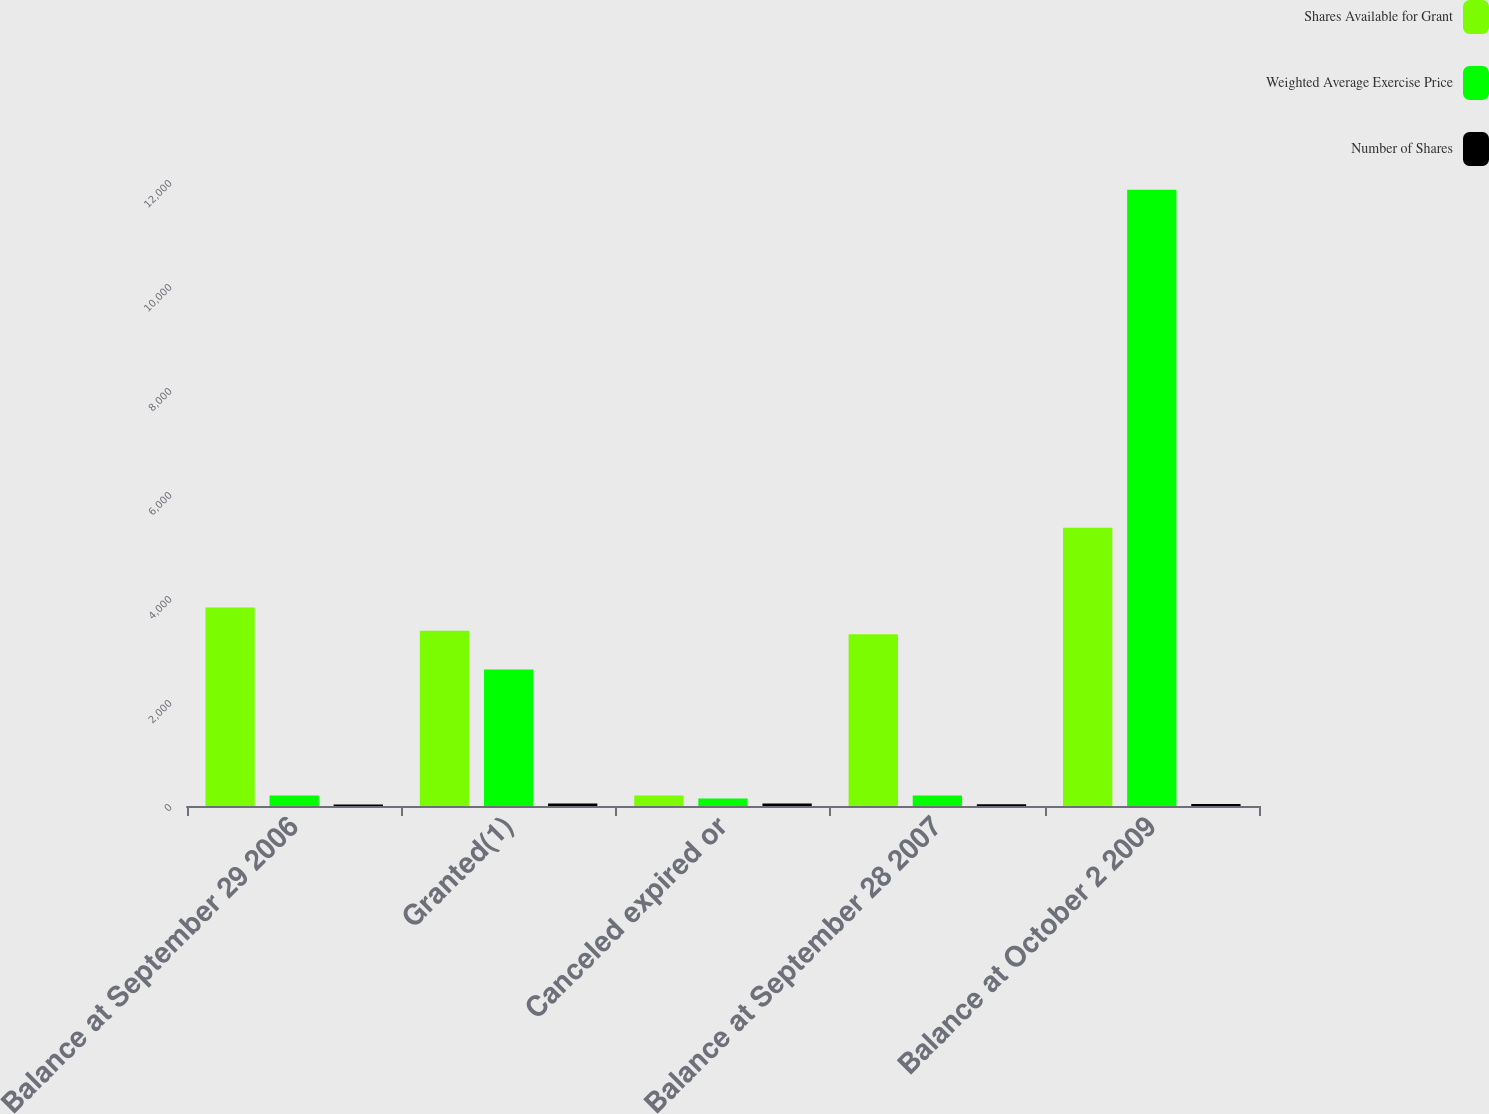<chart> <loc_0><loc_0><loc_500><loc_500><stacked_bar_chart><ecel><fcel>Balance at September 29 2006<fcel>Granted(1)<fcel>Canceled expired or<fcel>Balance at September 28 2007<fcel>Balance at October 2 2009<nl><fcel>Shares Available for Grant<fcel>3816<fcel>3371<fcel>204<fcel>3304<fcel>5352<nl><fcel>Weighted Average Exercise Price<fcel>201.5<fcel>2624<fcel>146<fcel>201.5<fcel>11853<nl><fcel>Number of Shares<fcel>28.9<fcel>50.38<fcel>46.45<fcel>33.75<fcel>40.59<nl></chart> 